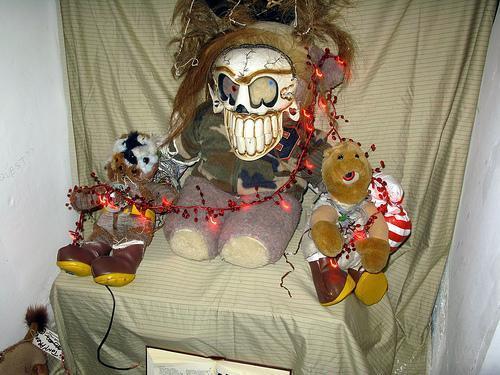How many stuffed figures are sitting?
Give a very brief answer. 3. How many figures are draped in lights?
Give a very brief answer. 3. 